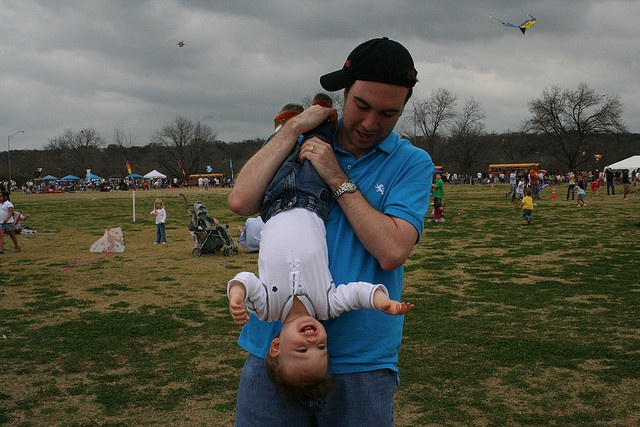Describe the objects in this image and their specific colors. I can see people in darkgray, black, darkblue, blue, and gray tones, people in darkgray, black, gray, olive, and maroon tones, people in darkgray, black, maroon, and gray tones, people in darkgray, olive, black, and gray tones, and kite in darkgray and gray tones in this image. 